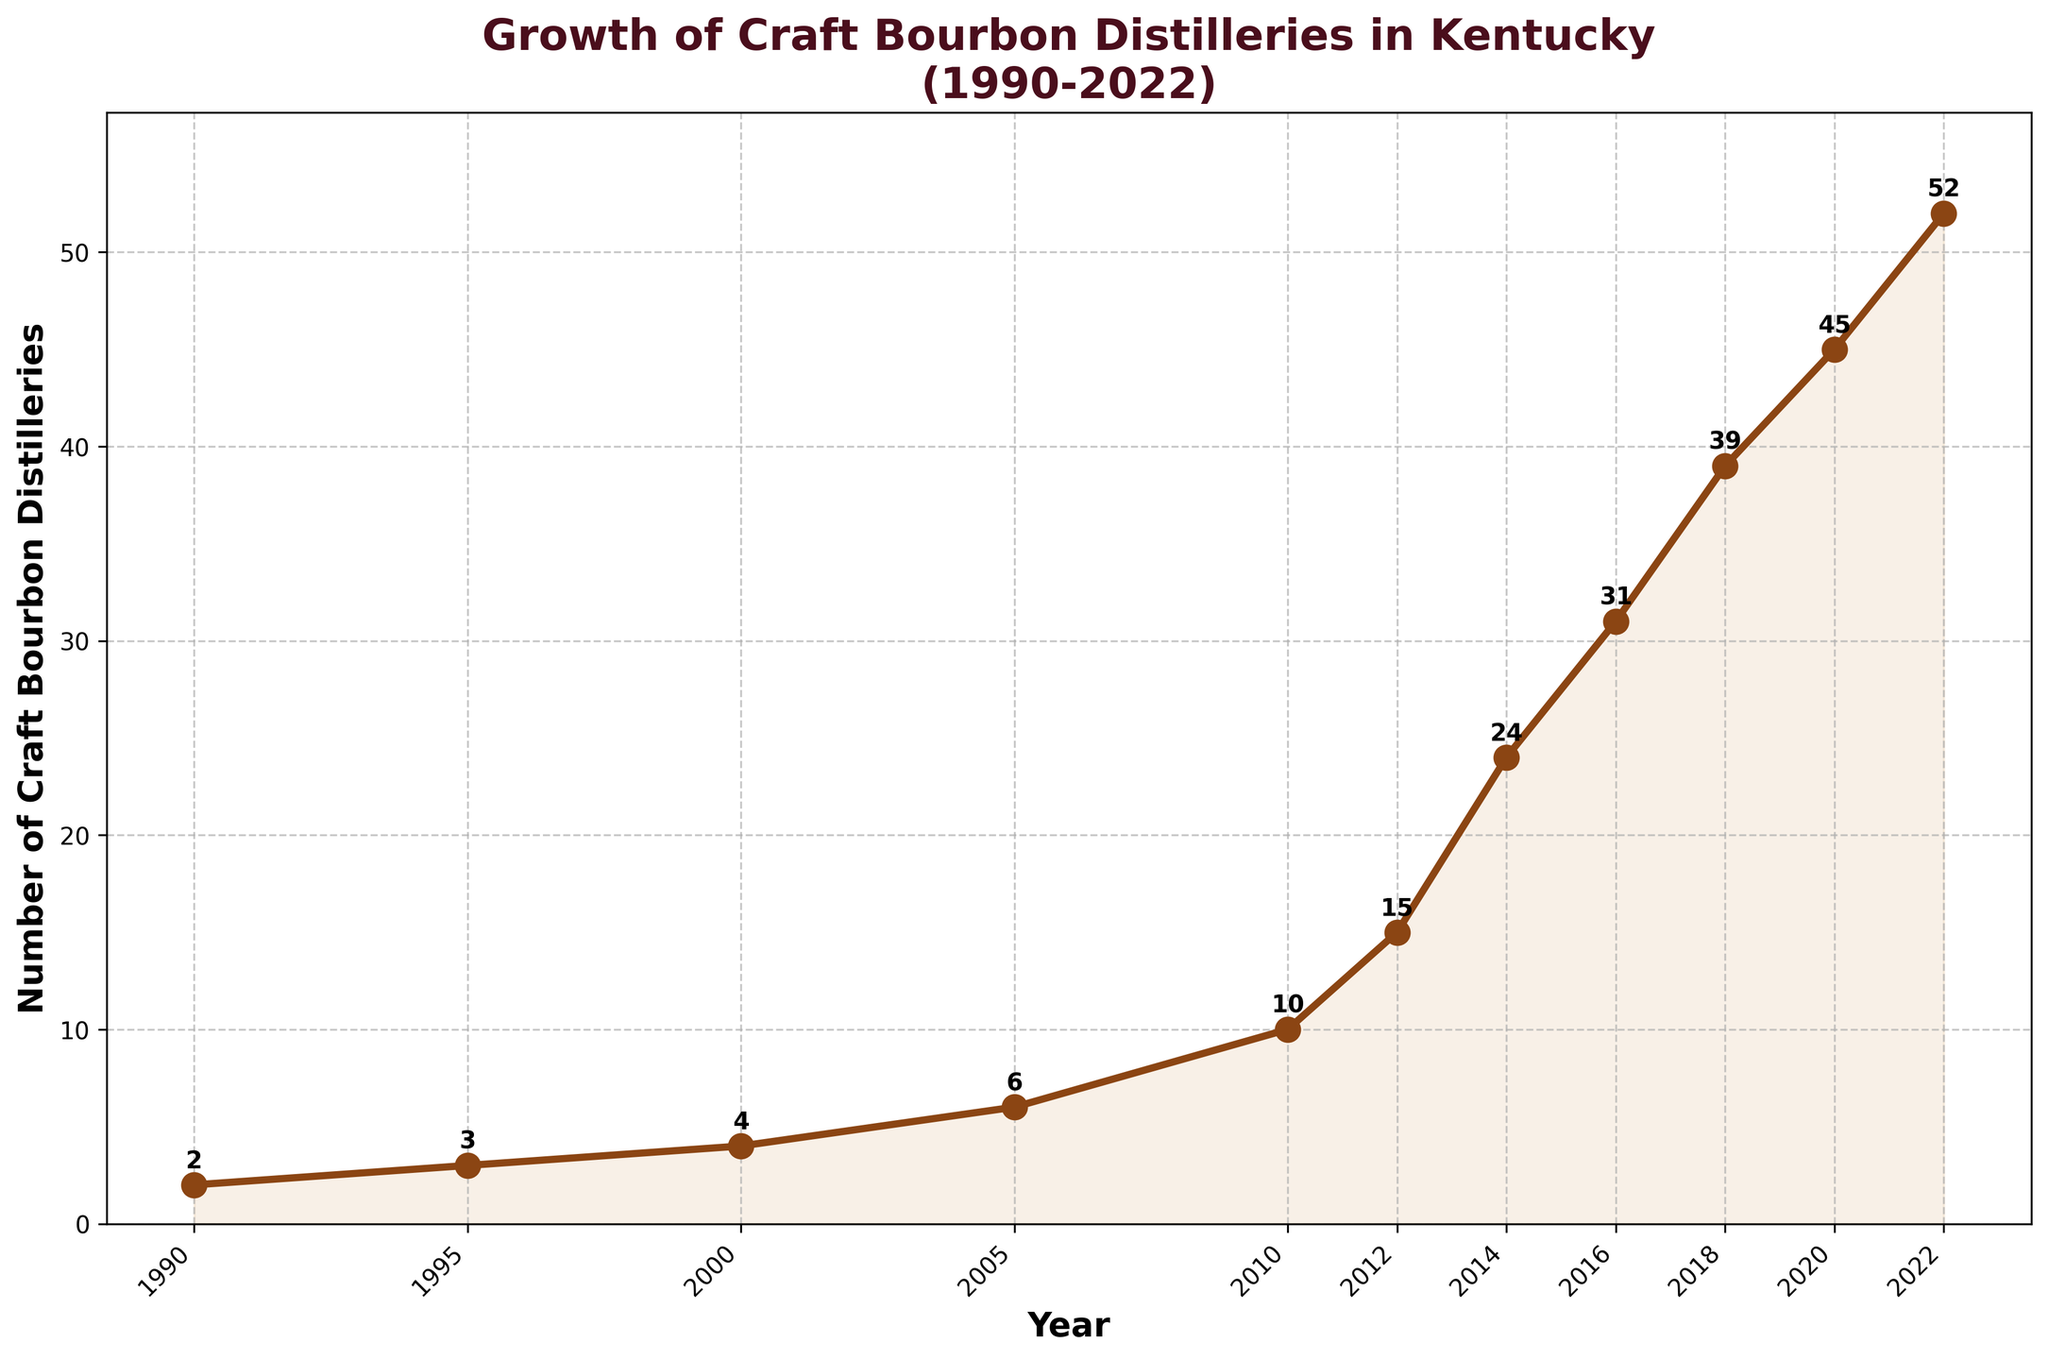what is the range of the number of craft bourbon distilleries between 1990 and 2022? The range is calculated by subtracting the smallest number of distilleries from the largest number of distilleries. From the figure, the smallest number is 2 in 1990, and the largest number is 52 in 2022. So, the range is 52 - 2 = 50.
Answer: 50 Between which consecutive years did craft bourbon distilleries experience the largest growth? To find the largest growth, calculate the difference in the number of distilleries between each pair of consecutive years and find the maximum difference. The differences are: 1 (1990-1995), 1 (1995-2000), 2 (2000-2005), 4 (2005-2010), 5 (2010-2012), 9 (2012-2014), 7 (2014-2016), 8 (2016-2018), 6 (2018-2020), 7 (2020-2022). The largest difference is 9 between 2012 and 2014.
Answer: 2012-2014 How many more craft bourbon distilleries were there in 2022 compared to 2005? Subtract the number of distilleries in 2005 from the number of distilleries in 2022. In 2022, there were 52 distilleries and in 2005, there were 6 distilleries. So, 52 - 6 = 46.
Answer: 46 During which period did the number of craft bourbon distilleries double for the first time? Identify the period in which the number of distilleries first doubles its previous value. The number of distilleries doubles from 3 in 1995 to 6 in 2005. This is the first instance of doubling.
Answer: 1995-2005 Which year marks the start of a significant upward trend in the number of distilleries? Visually, a significant upward trend is noticeable starting from 2010. Before 2010, the growth rate is relatively modest. After 2010, the growth becomes steeper.
Answer: 2010 By how much did the number of distilleries increase from 2016 to 2020? Subtract the number of distilleries in 2016 from the number of distilleries in 2020. In 2020, there were 45 distilleries and in 2016, there were 31. So, 45 - 31 = 14.
Answer: 14 What is the average number of distilleries per year since 1990? Calculate the average by summing the number of distilleries for each year and dividing by the number of years. Summing all values: 2 + 3 + 4 + 6 + 10 + 15 + 24 + 31 + 39 + 45 + 52 = 231. There are 11 data points (years). So, the average is 231 / 11 = 21.
Answer: 21 Which years experienced exponential growth in the number of distilleries? Exponential growth suggests a rapid and substantial increase. Primarily, the years from 2010 to 2014 show this pattern, where the number increases from 10 to 24 within four years.
Answer: 2010-2014 